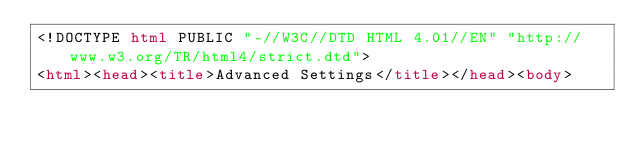<code> <loc_0><loc_0><loc_500><loc_500><_HTML_><!DOCTYPE html PUBLIC "-//W3C//DTD HTML 4.01//EN" "http://www.w3.org/TR/html4/strict.dtd">
<html><head><title>Advanced Settings</title></head><body></code> 